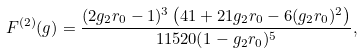<formula> <loc_0><loc_0><loc_500><loc_500>F ^ { ( 2 ) } ( g ) = \frac { ( 2 g _ { 2 } r _ { 0 } - 1 ) ^ { 3 } \left ( 4 1 + 2 1 g _ { 2 } r _ { 0 } - 6 ( g _ { 2 } r _ { 0 } ) ^ { 2 } \right ) } { 1 1 5 2 0 ( 1 - g _ { 2 } r _ { 0 } ) ^ { 5 } } ,</formula> 